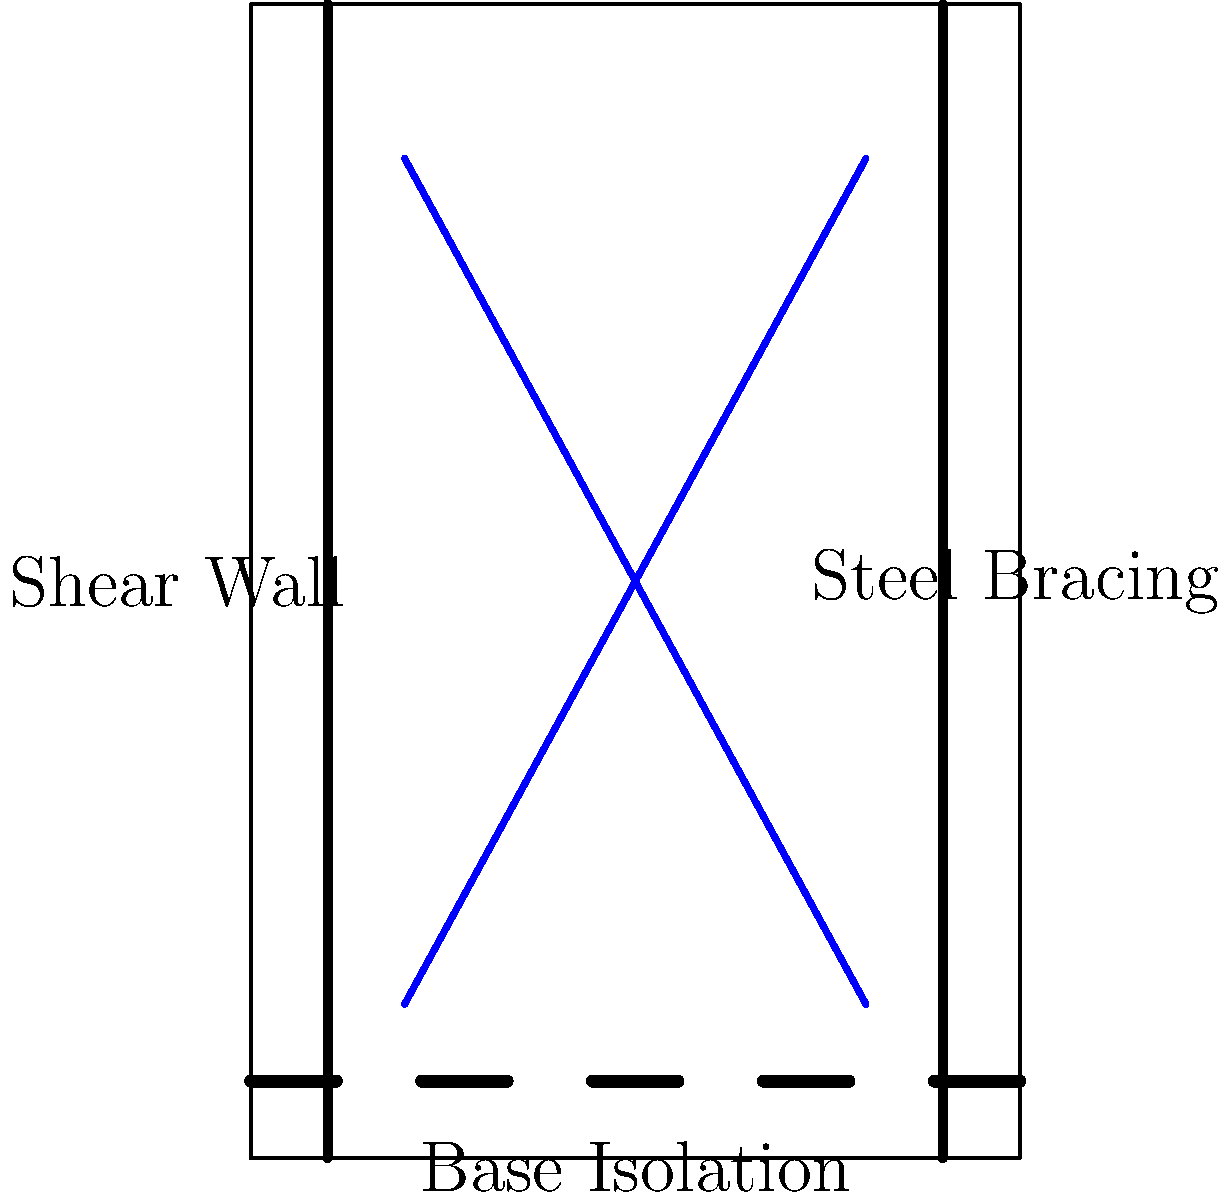As a politician advocating for affordable college education, you're visiting a university's engineering department to understand their research on earthquake-resistant building designs. The diagram shows three common structural reinforcement methods. Which of these methods is most effective in absorbing and dissipating seismic energy, potentially reducing damage and the need for costly repairs in educational facilities? To answer this question, let's examine each of the three structural reinforcement methods shown in the diagram:

1. Shear Walls: These are vertical elements designed to resist lateral forces parallel to the wall. While effective in providing lateral stability, they don't specifically absorb or dissipate energy.

2. Steel Bracing: This method involves adding diagonal steel members to a building's frame. It increases the structure's stiffness and helps distribute lateral loads. However, it doesn't primarily focus on energy dissipation.

3. Base Isolation: This system involves placing flexible pads (isolators) between the building and its foundation. During an earthquake:
   a) The isolators allow the building to move horizontally, separate from the ground motion.
   b) This movement reduces the seismic forces transferred to the structure.
   c) The isolators absorb and dissipate a significant amount of the earthquake's energy.
   d) This results in less damage to the building and its contents.

Among these three methods, base isolation is the most effective in absorbing and dissipating seismic energy. It can significantly reduce the acceleration and forces experienced by the building during an earthquake, potentially leading to less damage and lower repair costs.

For a politician focused on making college education more affordable, understanding that base isolation can reduce long-term costs associated with earthquake damage and repairs in educational facilities is crucial. This knowledge can inform policy decisions related to building codes and funding for seismic upgrades in schools and universities.
Answer: Base isolation 